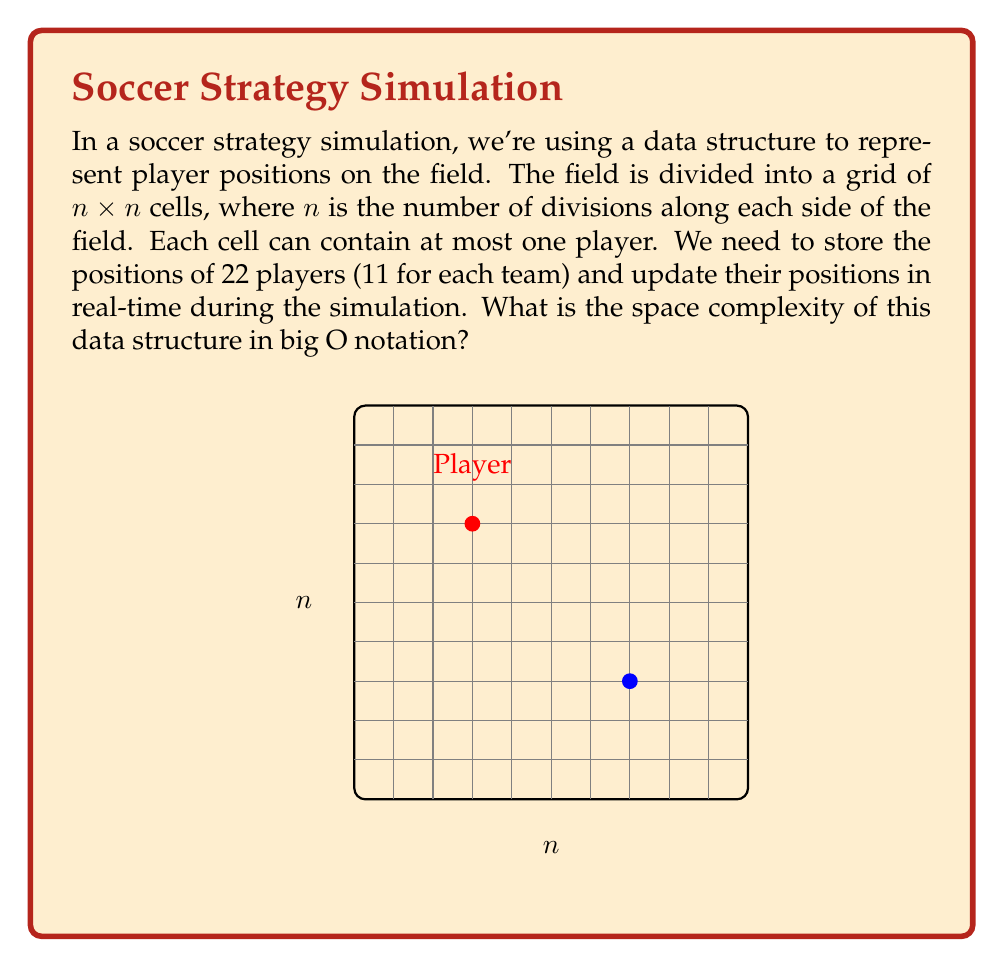Give your solution to this math problem. Let's break this down step-by-step:

1) The field is represented by an $n \times n$ grid. This means we have $n^2$ cells in total.

2) Each cell needs to store information about whether it contains a player or not. This can be represented by a boolean value (1 bit) or a small integer if we want to store player IDs.

3) The space required for each cell is constant, let's call it $c$. So the total space for the grid is $O(cn^2)$.

4) Since $c$ is a constant, we can simplify this to $O(n^2)$.

5) We also need to store the positions of 22 players. Each player's position can be represented by two coordinates $(x,y)$, where $0 \leq x,y < n$.

6) Storing each coordinate requires $\log n$ bits (as we need to represent numbers up to $n$).

7) So, for 22 players, we need $22 \cdot 2 \cdot \log n = 44 \log n$ bits.

8) The space complexity for player positions is therefore $O(\log n)$.

9) Combining the space for the grid and player positions, we get:
   $O(n^2 + \log n)$

10) As $n$ grows, $n^2$ dominates $\log n$, so we can simplify this to $O(n^2)$.

Therefore, the overall space complexity of this data structure is $O(n^2)$.
Answer: $O(n^2)$ 